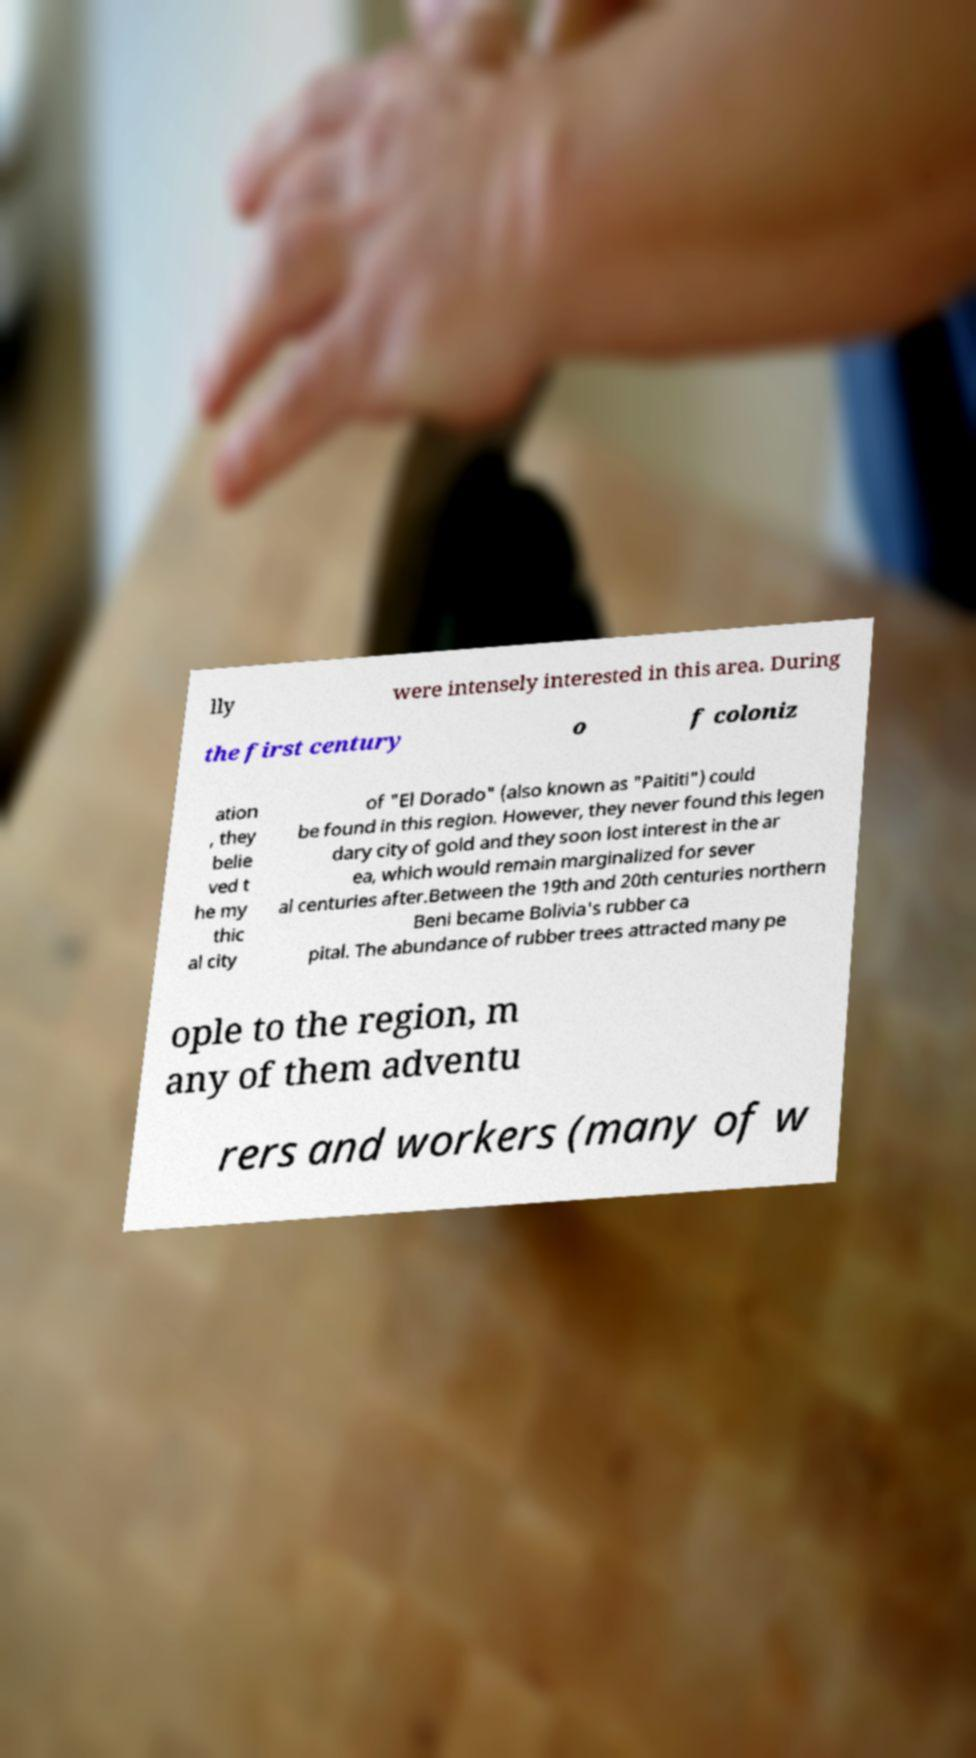I need the written content from this picture converted into text. Can you do that? lly were intensely interested in this area. During the first century o f coloniz ation , they belie ved t he my thic al city of "El Dorado" (also known as "Paititi") could be found in this region. However, they never found this legen dary city of gold and they soon lost interest in the ar ea, which would remain marginalized for sever al centuries after.Between the 19th and 20th centuries northern Beni became Bolivia's rubber ca pital. The abundance of rubber trees attracted many pe ople to the region, m any of them adventu rers and workers (many of w 